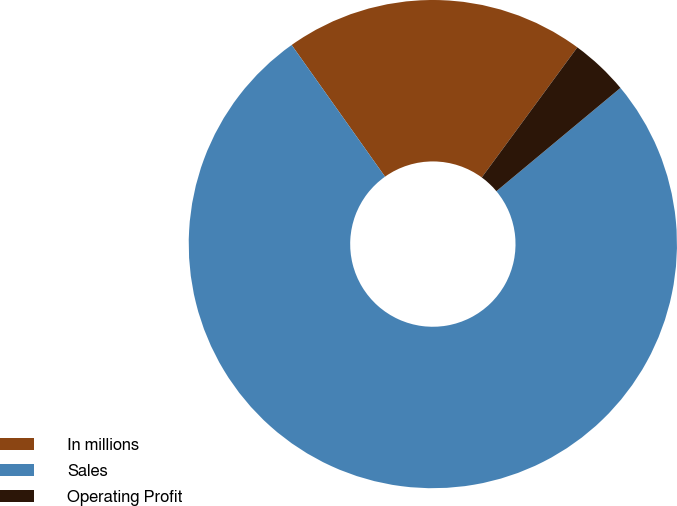Convert chart. <chart><loc_0><loc_0><loc_500><loc_500><pie_chart><fcel>In millions<fcel>Sales<fcel>Operating Profit<nl><fcel>19.9%<fcel>76.23%<fcel>3.87%<nl></chart> 